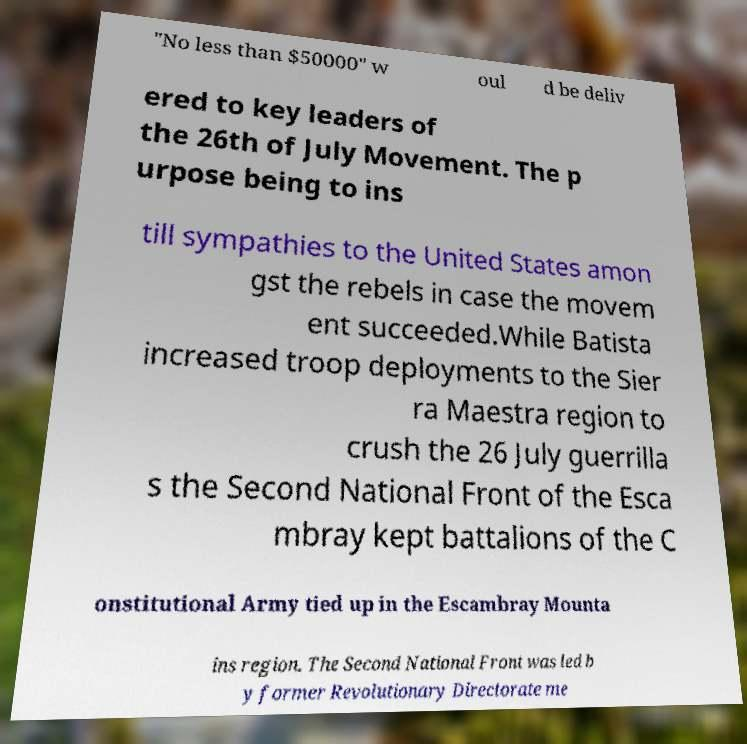Please read and relay the text visible in this image. What does it say? "No less than $50000" w oul d be deliv ered to key leaders of the 26th of July Movement. The p urpose being to ins till sympathies to the United States amon gst the rebels in case the movem ent succeeded.While Batista increased troop deployments to the Sier ra Maestra region to crush the 26 July guerrilla s the Second National Front of the Esca mbray kept battalions of the C onstitutional Army tied up in the Escambray Mounta ins region. The Second National Front was led b y former Revolutionary Directorate me 